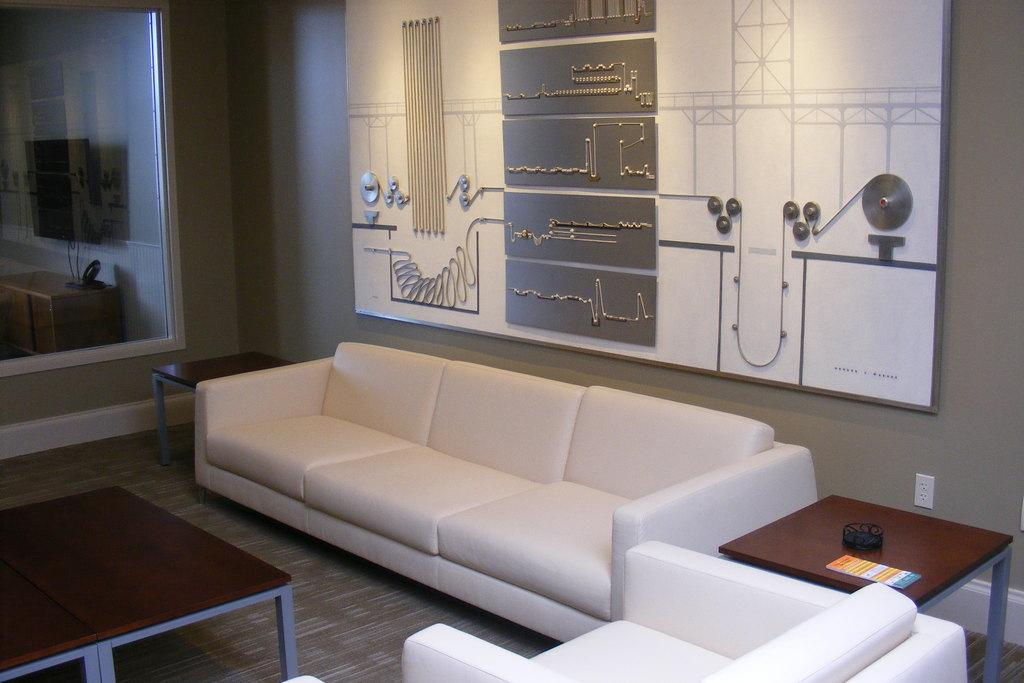What type of furniture is present in the image? There is a sofa set and tables in the image. What is on one of the tables? There are two things on one of the tables. What can be seen in the background of the image? There is a wall and a glass in the background of the image. What type of record is being played on the sofa set in the image? There is no record or music player present in the image; it only features a sofa set, tables, and items on the tables. 